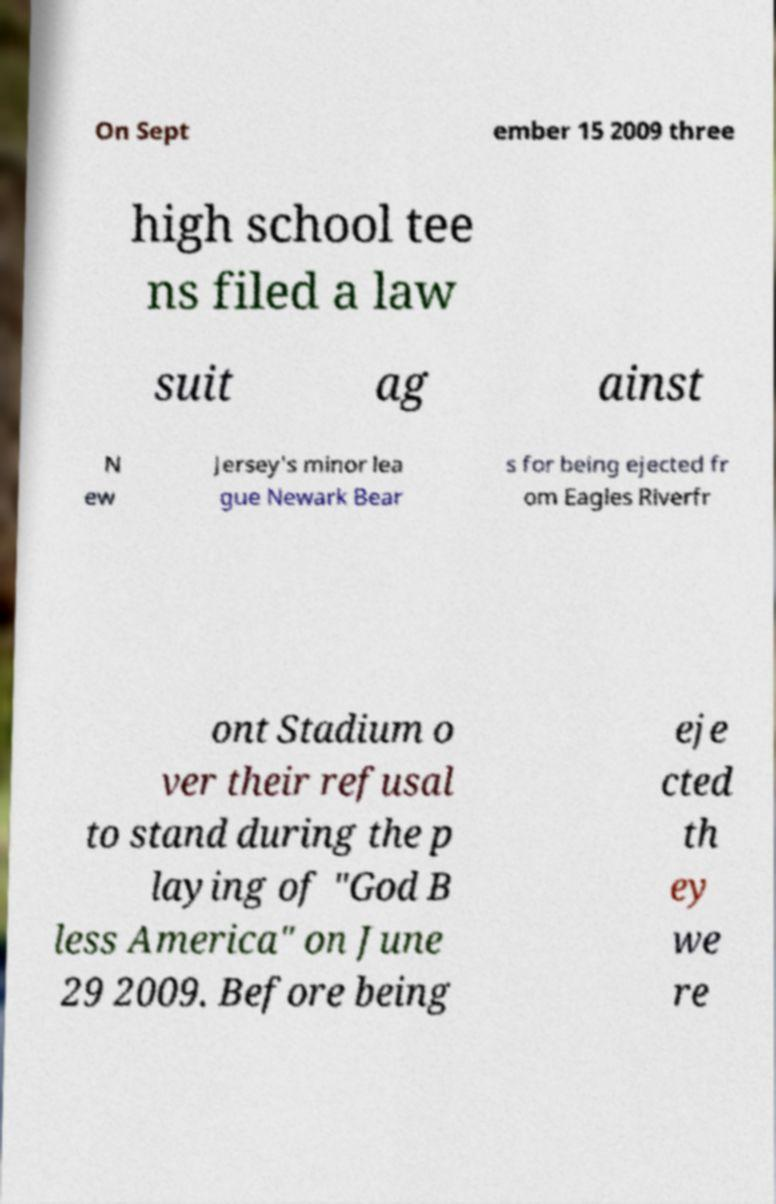Please read and relay the text visible in this image. What does it say? On Sept ember 15 2009 three high school tee ns filed a law suit ag ainst N ew Jersey's minor lea gue Newark Bear s for being ejected fr om Eagles Riverfr ont Stadium o ver their refusal to stand during the p laying of "God B less America" on June 29 2009. Before being eje cted th ey we re 